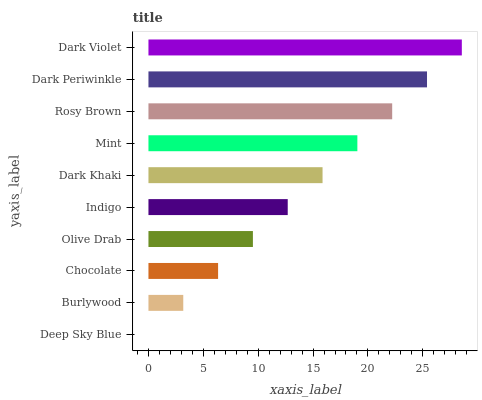Is Deep Sky Blue the minimum?
Answer yes or no. Yes. Is Dark Violet the maximum?
Answer yes or no. Yes. Is Burlywood the minimum?
Answer yes or no. No. Is Burlywood the maximum?
Answer yes or no. No. Is Burlywood greater than Deep Sky Blue?
Answer yes or no. Yes. Is Deep Sky Blue less than Burlywood?
Answer yes or no. Yes. Is Deep Sky Blue greater than Burlywood?
Answer yes or no. No. Is Burlywood less than Deep Sky Blue?
Answer yes or no. No. Is Dark Khaki the high median?
Answer yes or no. Yes. Is Indigo the low median?
Answer yes or no. Yes. Is Dark Periwinkle the high median?
Answer yes or no. No. Is Dark Violet the low median?
Answer yes or no. No. 